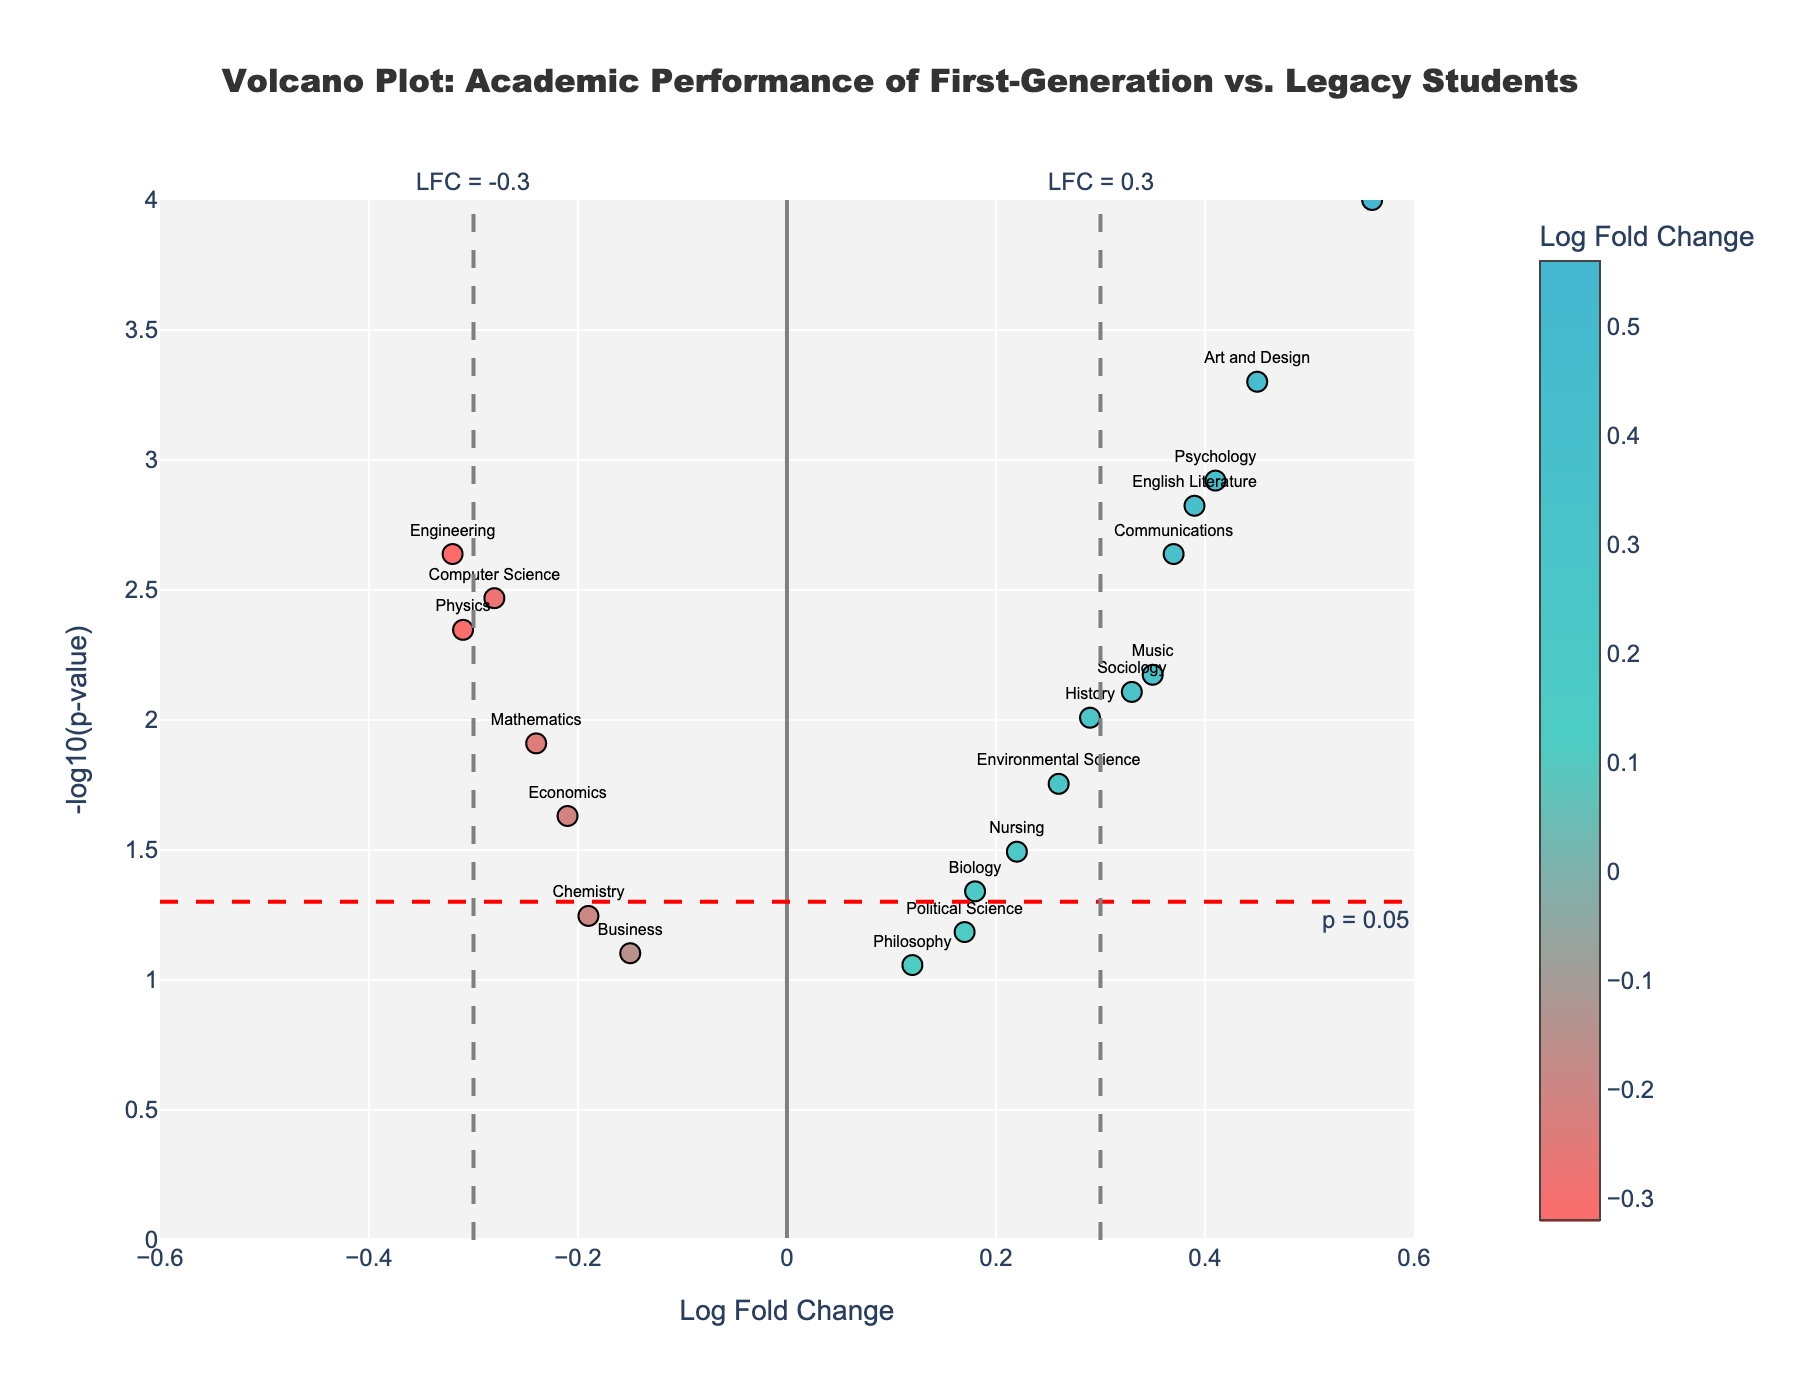what is the title of the figure? The title is usually located at the top of the figure. It is centered and displayed in a larger, bold font.
Answer: Volcano Plot: Academic Performance of First-Generation vs. Legacy Students What does the x-axis represent? The x-axis is labeled at the bottom of the plot, typically in a bold font, and it indicates the variable it measures.
Answer: Log Fold Change What does the y-axis represent? The y-axis is labeled on the left side of the plot, typically in a bold font, and it indicates the variable it measures.
Answer: -log10(p-value) How many majors are plotted in the figure? Each data point in the plot represents a specific major. Count the individual points or check how many different labels are there.
Answer: 20 Which major has the highest -log10(p-value)? Identify the point that is plotted highest (along the y-axis) and refer to its label.
Answer: Education Which major shows the largest positive log fold change? Identify the point that is plotted furthest to the right (along the x-axis) and refer to its label.
Answer: Education Which major shows the largest negative log fold change? Identify the point that is plotted furthest to the left (along the x-axis) and refer to its label.
Answer: Engineering Are there any majors with a p-value greater than 0.05? Check for points not exceeding the horizontal dashed line representing the p-value threshold. Identify these points by their labels.
Answer: Yes, Business, Chemistry, Political Science, and Philosophy How many majors have a significant difference in performance between first-generation and legacy students? Significant differences are typically indicated by a -log10(p-value) above the horizontal threshold line (p = 0.05). Count the points above this line.
Answer: 16 Which majors fall within the insignificant Log Fold Change range between -0.3 and 0.3? Look for points that fit between the two vertical dashed lines indicating fold change thresholds and verify their position with respect to these lines.
Answer: Biology, Business, Psychology, English Literature, Sociology, Mathematics, History, Political Science, Nursing, Environmental Science, Communications, Philosophy, Music 